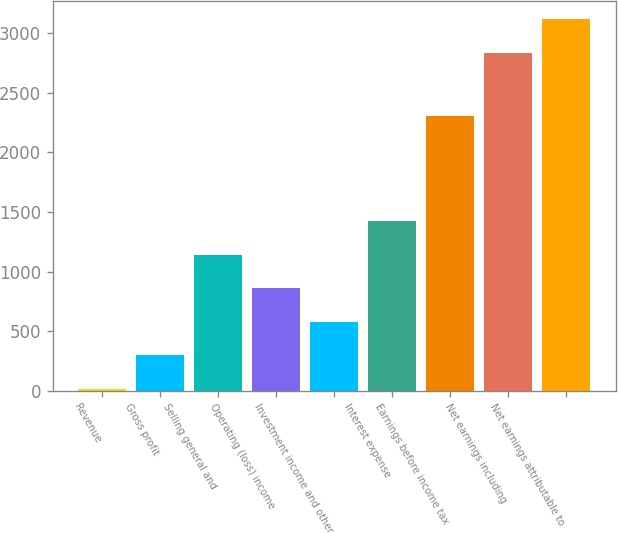<chart> <loc_0><loc_0><loc_500><loc_500><bar_chart><fcel>Revenue<fcel>Gross profit<fcel>Selling general and<fcel>Operating (loss) income<fcel>Investment income and other<fcel>Interest expense<fcel>Earnings before income tax<fcel>Net earnings including<fcel>Net earnings attributable to<nl><fcel>16<fcel>297.7<fcel>1142.8<fcel>861.1<fcel>579.4<fcel>1424.5<fcel>2301<fcel>2833<fcel>3114.7<nl></chart> 